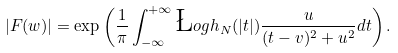<formula> <loc_0><loc_0><loc_500><loc_500>| F ( w ) | = \exp \left ( \frac { 1 } { \pi } \int _ { - \infty } ^ { + \infty } \L o g h _ { N } ( | t | ) \frac { u } { ( t - v ) ^ { 2 } + u ^ { 2 } } d t \right ) .</formula> 